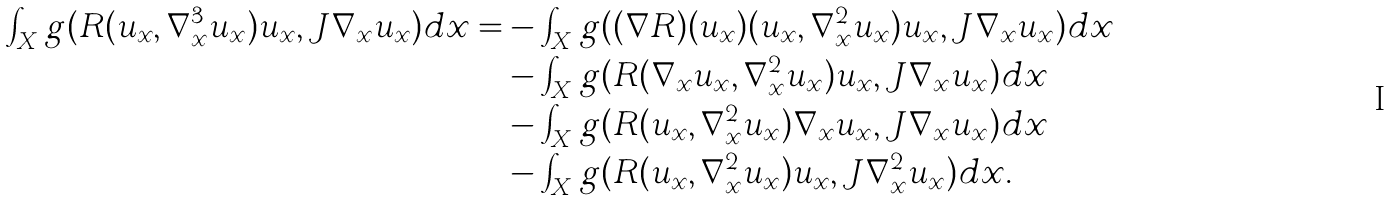Convert formula to latex. <formula><loc_0><loc_0><loc_500><loc_500>\int _ { X } g ( R ( u _ { x } , \nabla _ { x } ^ { 3 } u _ { x } ) u _ { x } , J \nabla _ { x } u _ { x } ) d x = & - \int _ { X } g ( ( \nabla R ) ( u _ { x } ) ( u _ { x } , \nabla _ { x } ^ { 2 } u _ { x } ) u _ { x } , J \nabla _ { x } u _ { x } ) d x \\ & - \int _ { X } g ( R ( \nabla _ { x } u _ { x } , \nabla _ { x } ^ { 2 } u _ { x } ) u _ { x } , J \nabla _ { x } u _ { x } ) d x \\ & - \int _ { X } g ( R ( u _ { x } , \nabla _ { x } ^ { 2 } u _ { x } ) \nabla _ { x } u _ { x } , J \nabla _ { x } u _ { x } ) d x \\ & - \int _ { X } g ( R ( u _ { x } , \nabla _ { x } ^ { 2 } u _ { x } ) u _ { x } , J \nabla _ { x } ^ { 2 } u _ { x } ) d x .</formula> 